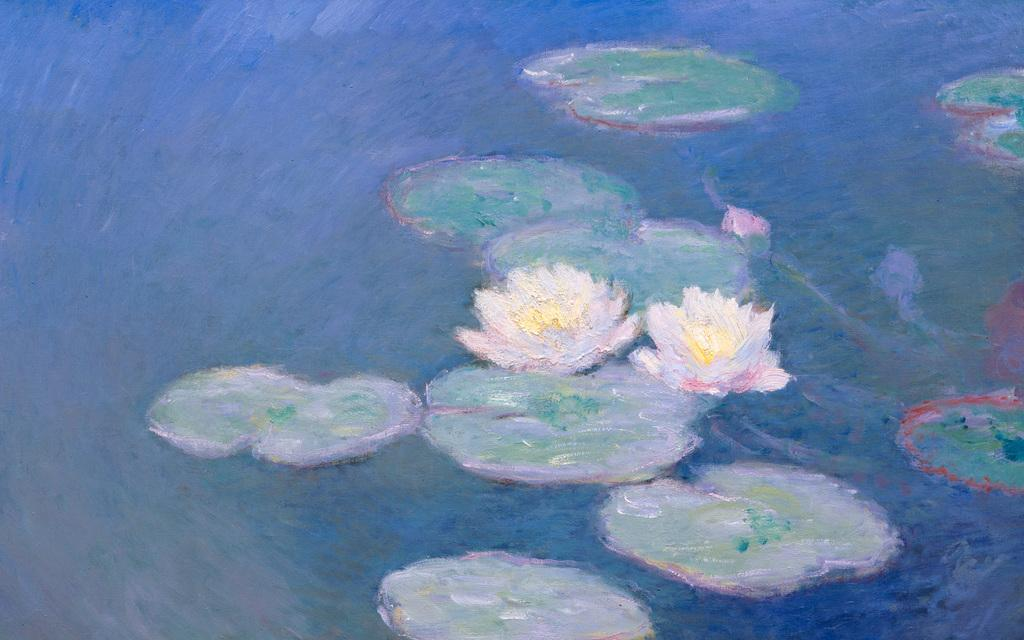What type of flowers are in the image? There are lotus flowers in the image. What color are the leaves in the image? The leaves in the image are green. Where are the lotus flowers and green leaves located? The lotus flowers and green leaves are on the water. Can you hear the drum being played in the image? There is no drum or sound present in the image; it is a still image of lotus flowers and green leaves on the water. 